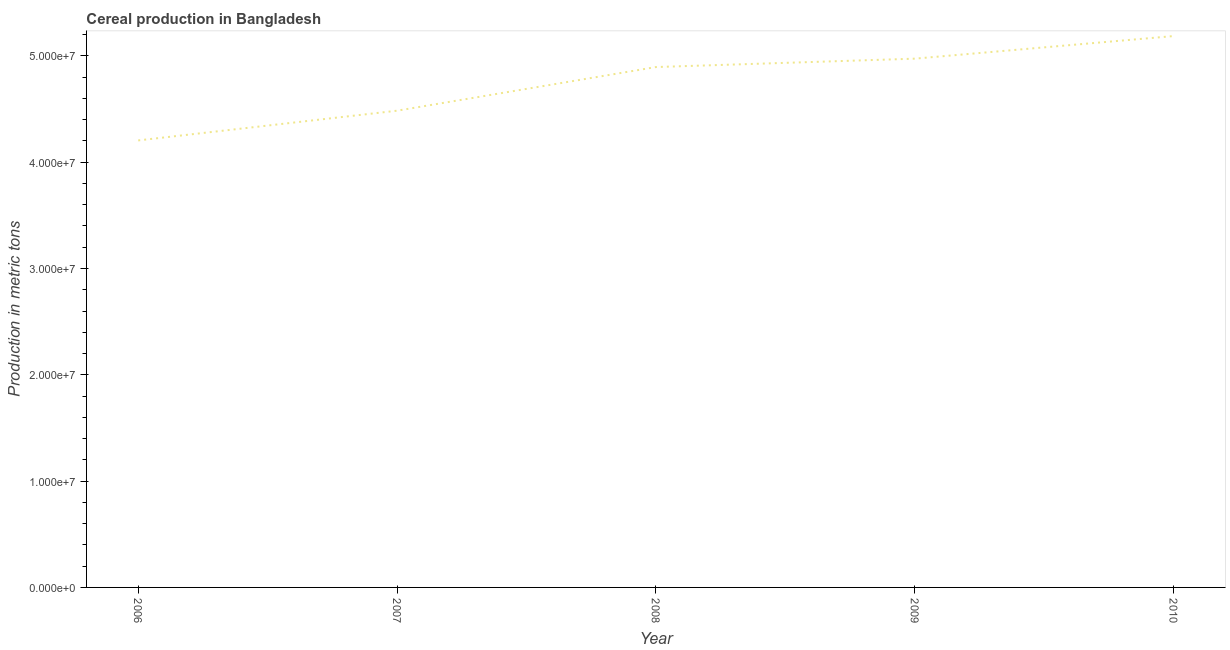What is the cereal production in 2006?
Your answer should be compact. 4.20e+07. Across all years, what is the maximum cereal production?
Ensure brevity in your answer.  5.19e+07. Across all years, what is the minimum cereal production?
Offer a terse response. 4.20e+07. In which year was the cereal production maximum?
Keep it short and to the point. 2010. In which year was the cereal production minimum?
Ensure brevity in your answer.  2006. What is the sum of the cereal production?
Provide a short and direct response. 2.37e+08. What is the difference between the cereal production in 2008 and 2010?
Keep it short and to the point. -2.92e+06. What is the average cereal production per year?
Ensure brevity in your answer.  4.75e+07. What is the median cereal production?
Provide a succinct answer. 4.89e+07. Do a majority of the years between 2009 and 2007 (inclusive) have cereal production greater than 46000000 metric tons?
Ensure brevity in your answer.  No. What is the ratio of the cereal production in 2006 to that in 2008?
Offer a terse response. 0.86. Is the cereal production in 2007 less than that in 2008?
Give a very brief answer. Yes. What is the difference between the highest and the second highest cereal production?
Provide a succinct answer. 2.13e+06. What is the difference between the highest and the lowest cereal production?
Keep it short and to the point. 9.82e+06. In how many years, is the cereal production greater than the average cereal production taken over all years?
Make the answer very short. 3. How many lines are there?
Make the answer very short. 1. How many years are there in the graph?
Offer a very short reply. 5. What is the difference between two consecutive major ticks on the Y-axis?
Your response must be concise. 1.00e+07. Are the values on the major ticks of Y-axis written in scientific E-notation?
Provide a short and direct response. Yes. What is the title of the graph?
Provide a short and direct response. Cereal production in Bangladesh. What is the label or title of the Y-axis?
Your answer should be compact. Production in metric tons. What is the Production in metric tons in 2006?
Your response must be concise. 4.20e+07. What is the Production in metric tons in 2007?
Give a very brief answer. 4.48e+07. What is the Production in metric tons in 2008?
Provide a short and direct response. 4.89e+07. What is the Production in metric tons of 2009?
Your answer should be very brief. 4.97e+07. What is the Production in metric tons in 2010?
Make the answer very short. 5.19e+07. What is the difference between the Production in metric tons in 2006 and 2007?
Keep it short and to the point. -2.80e+06. What is the difference between the Production in metric tons in 2006 and 2008?
Your response must be concise. -6.90e+06. What is the difference between the Production in metric tons in 2006 and 2009?
Offer a terse response. -7.69e+06. What is the difference between the Production in metric tons in 2006 and 2010?
Give a very brief answer. -9.82e+06. What is the difference between the Production in metric tons in 2007 and 2008?
Offer a very short reply. -4.11e+06. What is the difference between the Production in metric tons in 2007 and 2009?
Your answer should be compact. -4.89e+06. What is the difference between the Production in metric tons in 2007 and 2010?
Your answer should be compact. -7.02e+06. What is the difference between the Production in metric tons in 2008 and 2009?
Your response must be concise. -7.89e+05. What is the difference between the Production in metric tons in 2008 and 2010?
Offer a very short reply. -2.92e+06. What is the difference between the Production in metric tons in 2009 and 2010?
Offer a terse response. -2.13e+06. What is the ratio of the Production in metric tons in 2006 to that in 2007?
Your answer should be compact. 0.94. What is the ratio of the Production in metric tons in 2006 to that in 2008?
Provide a short and direct response. 0.86. What is the ratio of the Production in metric tons in 2006 to that in 2009?
Ensure brevity in your answer.  0.84. What is the ratio of the Production in metric tons in 2006 to that in 2010?
Your response must be concise. 0.81. What is the ratio of the Production in metric tons in 2007 to that in 2008?
Your response must be concise. 0.92. What is the ratio of the Production in metric tons in 2007 to that in 2009?
Your answer should be very brief. 0.9. What is the ratio of the Production in metric tons in 2007 to that in 2010?
Your response must be concise. 0.86. What is the ratio of the Production in metric tons in 2008 to that in 2009?
Ensure brevity in your answer.  0.98. What is the ratio of the Production in metric tons in 2008 to that in 2010?
Give a very brief answer. 0.94. 